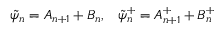Convert formula to latex. <formula><loc_0><loc_0><loc_500><loc_500>\tilde { \psi } _ { n } = A _ { n + 1 } + B _ { n } , \, \tilde { \psi } _ { n } ^ { + } = A _ { n + 1 } ^ { + } + B _ { n } ^ { + }</formula> 